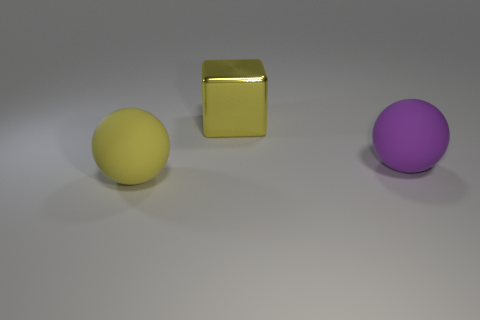How many other things are there of the same size as the purple rubber thing?
Offer a terse response. 2. There is a big thing that is on the left side of the large purple rubber object and in front of the large metal object; what is its shape?
Provide a short and direct response. Sphere. Is there a purple thing that has the same size as the metal block?
Provide a succinct answer. Yes. Do the rubber thing that is on the right side of the large yellow metallic block and the yellow metallic thing have the same shape?
Make the answer very short. No. Does the yellow matte object have the same shape as the purple matte thing?
Make the answer very short. Yes. Is there another big purple object of the same shape as the big metal thing?
Give a very brief answer. No. There is a yellow thing that is on the right side of the large object left of the block; what is its shape?
Your response must be concise. Cube. What color is the big sphere to the left of the big metallic cube?
Provide a short and direct response. Yellow. There is another sphere that is made of the same material as the big yellow ball; what is its size?
Your answer should be compact. Large. There is a yellow object that is the same shape as the large purple object; what size is it?
Your answer should be compact. Large. 